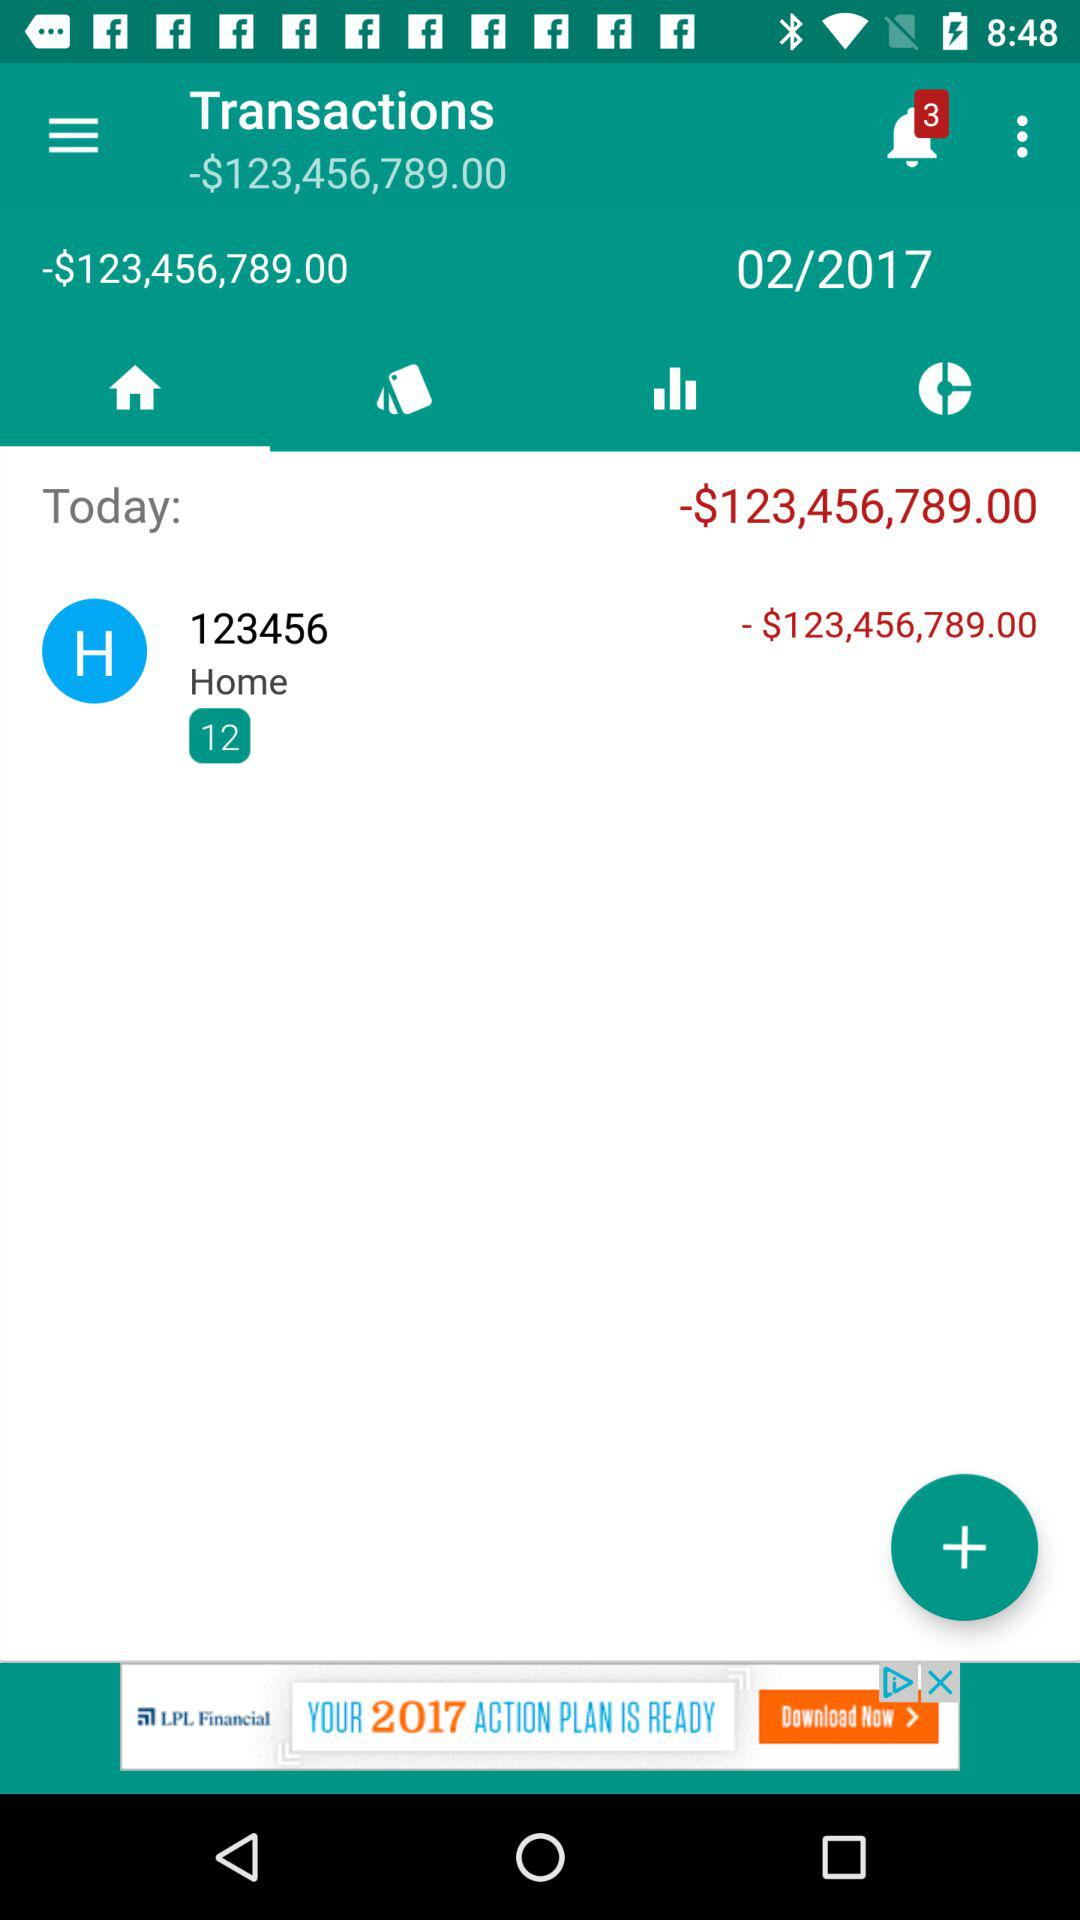What is the number of notifications? The number of notifications is 3. 